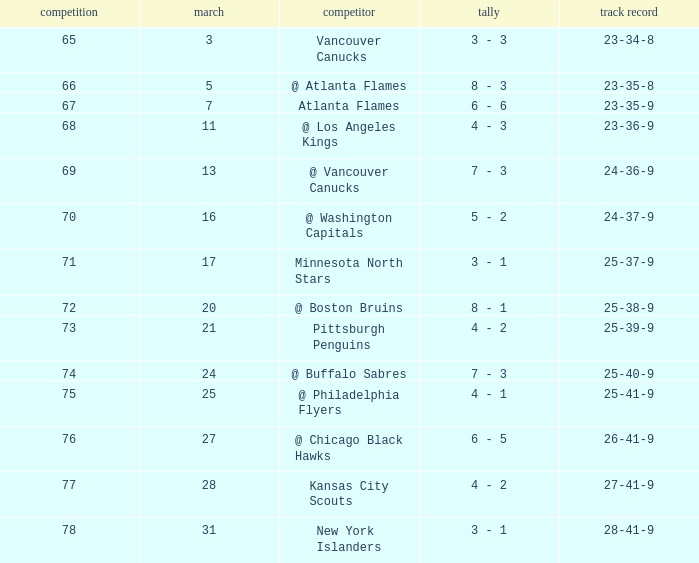What is the game associated with a score of 4 - 2, and a record of 25-39-9? 73.0. 